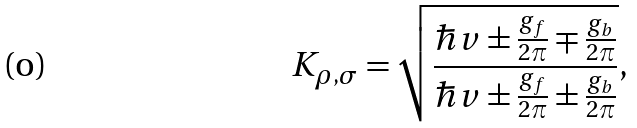<formula> <loc_0><loc_0><loc_500><loc_500>K _ { \rho , \sigma } = \sqrt { \frac { \hbar { v } \pm \frac { g _ { f } } { 2 \pi } \mp \frac { g _ { b } } { 2 \pi } } { \hbar { v } \pm \frac { g _ { f } } { 2 \pi } \pm \frac { g _ { b } } { 2 \pi } } } ,</formula> 